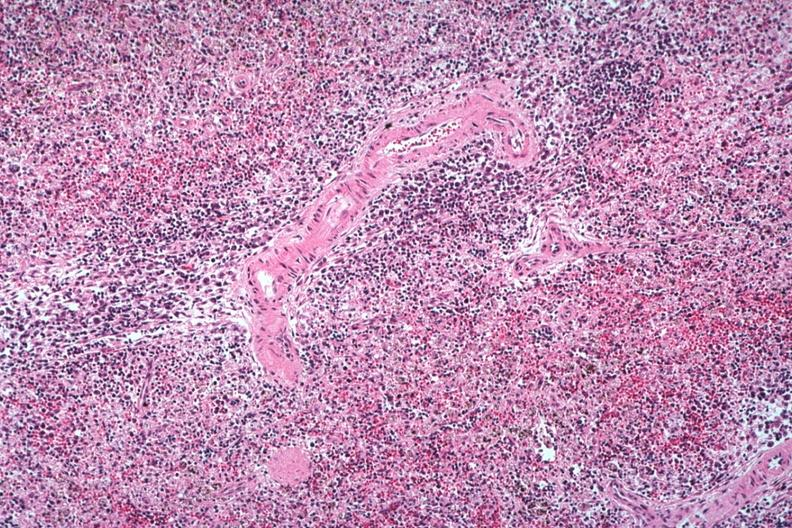what is well seen atypical cells surrounding splenic arteriole man probably died?
Answer the question using a single word or phrase. Of viral pneumonia likely to have been influenzae 